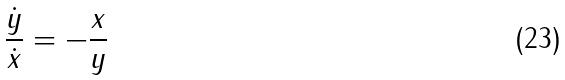Convert formula to latex. <formula><loc_0><loc_0><loc_500><loc_500>\frac { \dot { y } } { \dot { x } } = - \frac { x } { y }</formula> 